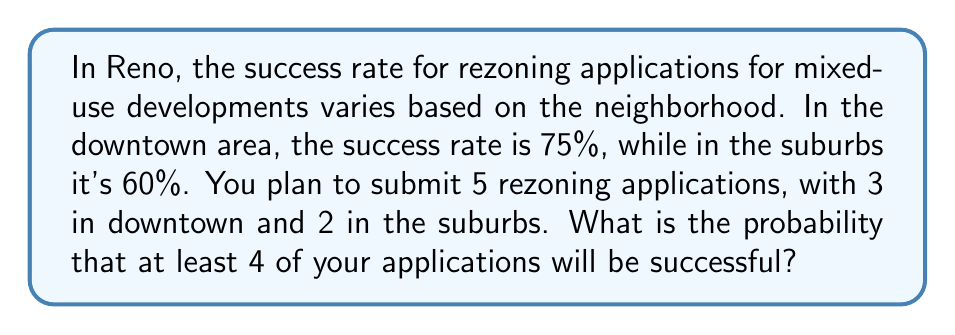Solve this math problem. Let's approach this step-by-step using the binomial probability distribution:

1) First, we need to calculate the probability of exactly 4 successes and exactly 5 successes, then add these probabilities together.

2) For 4 successes, we have two possible scenarios:
   a) 3 successes downtown and 1 in suburbs
   b) 2 successes downtown and 2 in suburbs

3) For 5 successes, there's only one scenario: 3 successes downtown and 2 in suburbs

4) Let's calculate each probability:

   a) P(3 downtown, 1 suburb) = $\binom{3}{3} \cdot 0.75^3 \cdot \binom{2}{1} \cdot 0.60^1 \cdot 0.40^1$
      $= 1 \cdot 0.421875 \cdot 2 \cdot 0.60 \cdot 0.40 = 0.202500$

   b) P(2 downtown, 2 suburbs) = $\binom{3}{2} \cdot 0.75^2 \cdot 0.25^1 \cdot \binom{2}{2} \cdot 0.60^2$
      $= 3 \cdot 0.5625 \cdot 0.25 \cdot 1 \cdot 0.36 = 0.151875$

   c) P(3 downtown, 2 suburbs) = $\binom{3}{3} \cdot 0.75^3 \cdot \binom{2}{2} \cdot 0.60^2$
      $= 1 \cdot 0.421875 \cdot 1 \cdot 0.36 = 0.151875$

5) The total probability is the sum of these three probabilities:
   $P(\text{at least 4 successes}) = 0.202500 + 0.151875 + 0.151875 = 0.506250$
Answer: 0.50625 